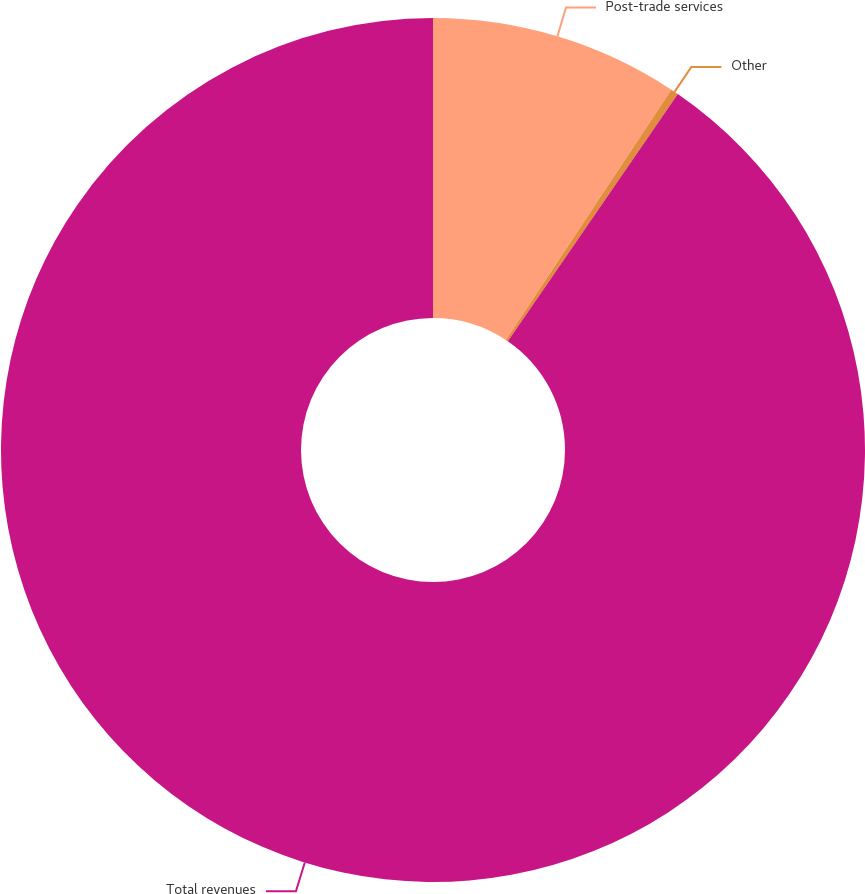Convert chart. <chart><loc_0><loc_0><loc_500><loc_500><pie_chart><fcel>Post-trade services<fcel>Other<fcel>Total revenues<nl><fcel>9.3%<fcel>0.29%<fcel>90.42%<nl></chart> 